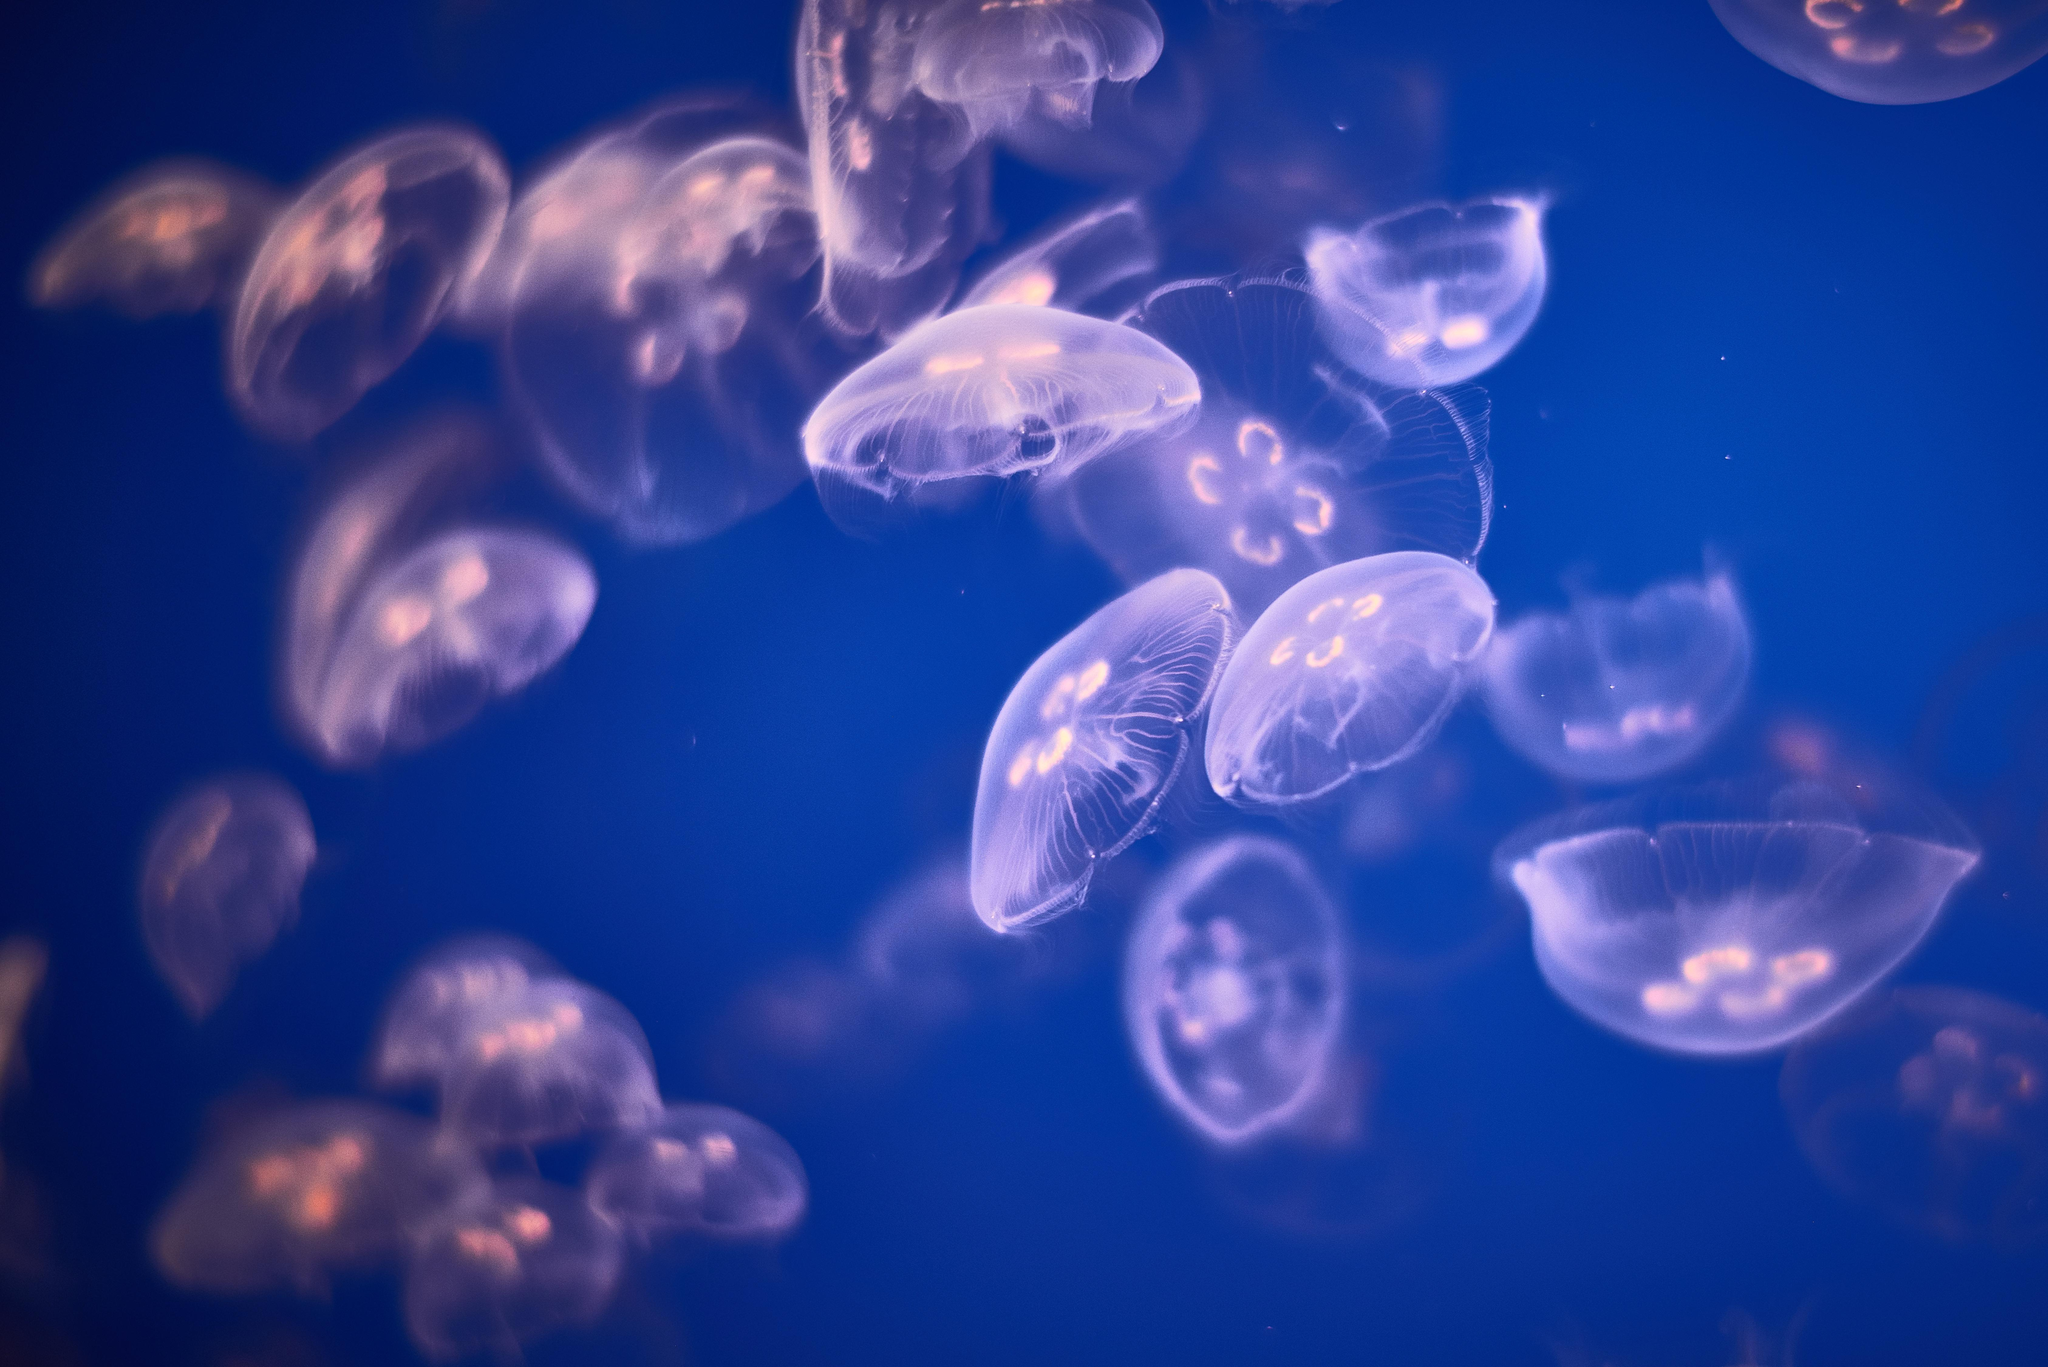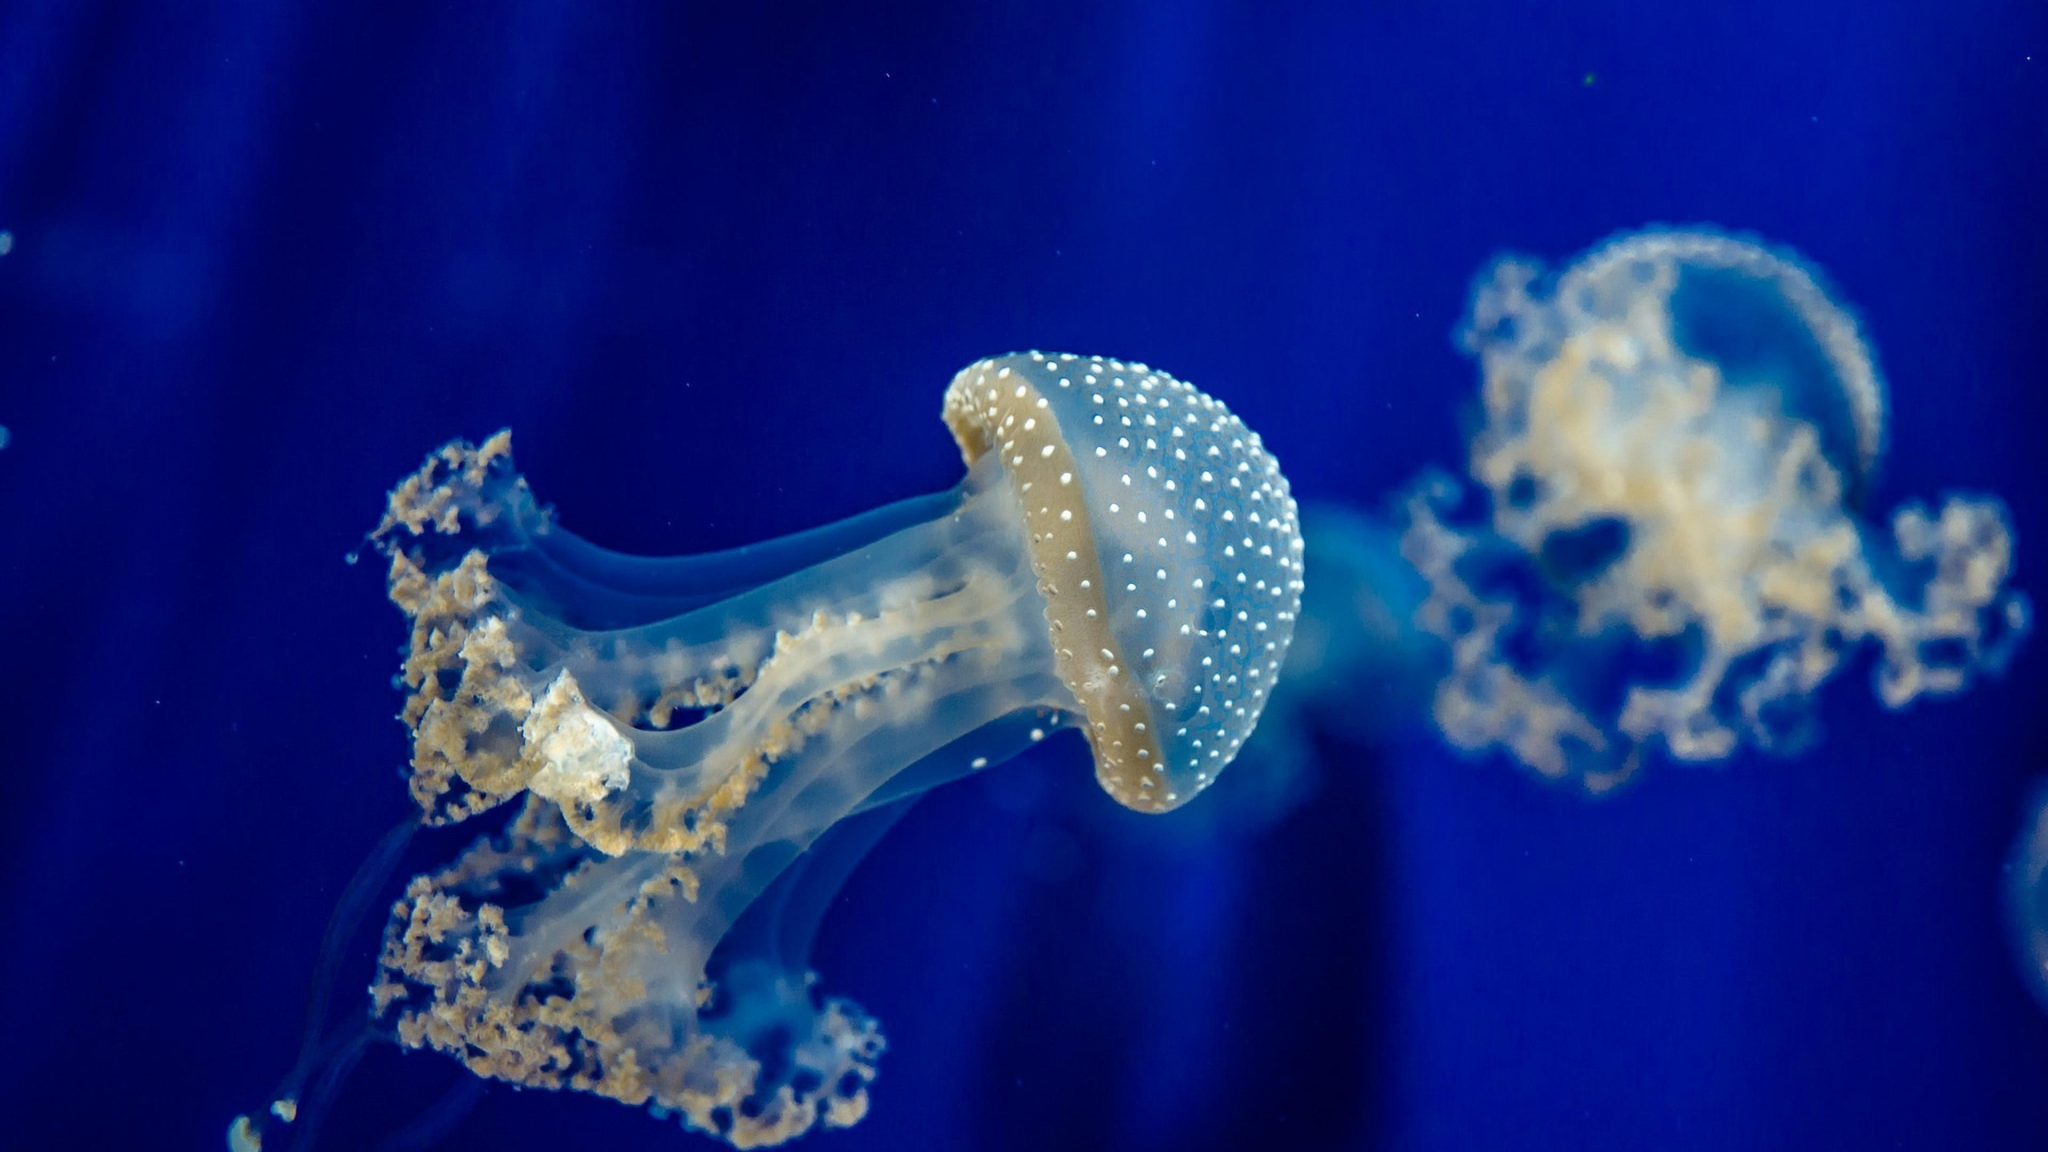The first image is the image on the left, the second image is the image on the right. Assess this claim about the two images: "Each image contains exactly one jellyfish, and one image shows a jellyfish with its 'cap' turned rightward and its long tentacles trailing horizontally to the left.". Correct or not? Answer yes or no. No. 